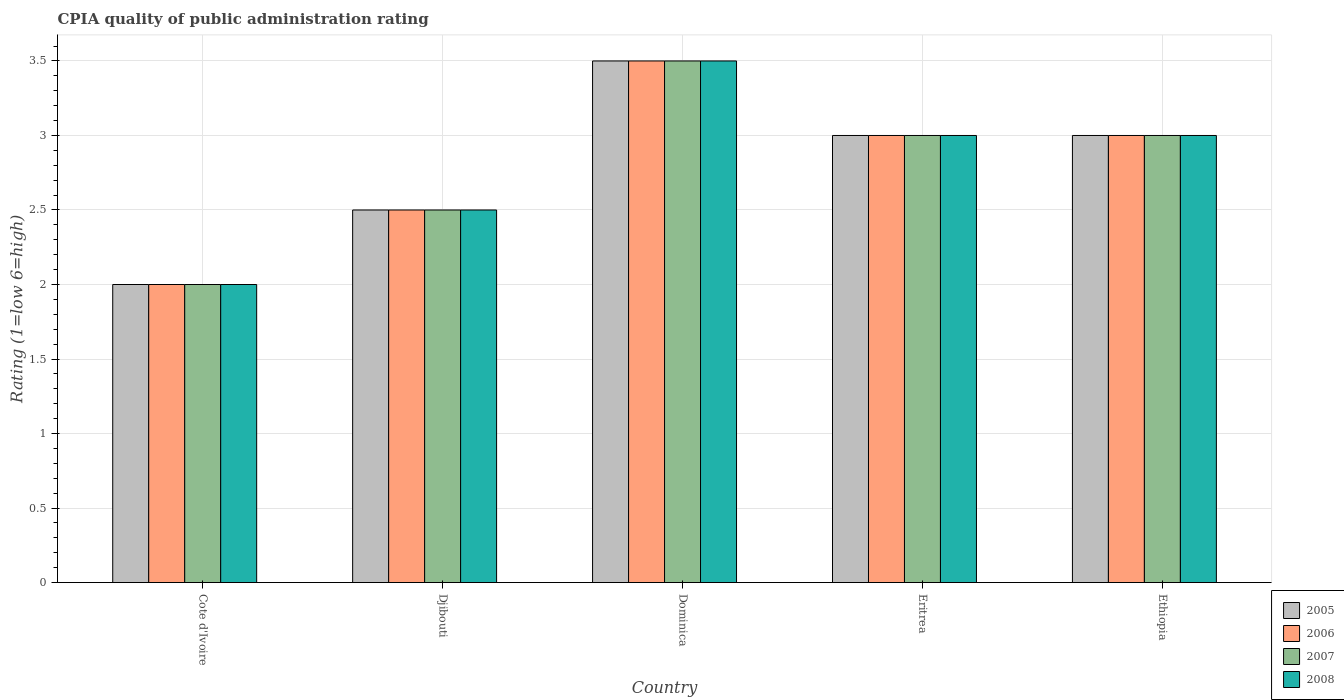How many bars are there on the 5th tick from the left?
Provide a short and direct response. 4. How many bars are there on the 5th tick from the right?
Offer a terse response. 4. What is the label of the 1st group of bars from the left?
Provide a succinct answer. Cote d'Ivoire. Across all countries, what is the maximum CPIA rating in 2005?
Your answer should be compact. 3.5. Across all countries, what is the minimum CPIA rating in 2005?
Provide a short and direct response. 2. In which country was the CPIA rating in 2008 maximum?
Make the answer very short. Dominica. In which country was the CPIA rating in 2008 minimum?
Ensure brevity in your answer.  Cote d'Ivoire. What is the total CPIA rating in 2008 in the graph?
Your answer should be very brief. 14. What is the difference between the CPIA rating in 2005 in Eritrea and the CPIA rating in 2006 in Cote d'Ivoire?
Ensure brevity in your answer.  1. Is the CPIA rating in 2007 in Dominica less than that in Eritrea?
Provide a short and direct response. No. Is the difference between the CPIA rating in 2007 in Djibouti and Dominica greater than the difference between the CPIA rating in 2008 in Djibouti and Dominica?
Offer a terse response. No. What is the difference between the highest and the second highest CPIA rating in 2005?
Make the answer very short. -0.5. In how many countries, is the CPIA rating in 2007 greater than the average CPIA rating in 2007 taken over all countries?
Offer a terse response. 3. Is the sum of the CPIA rating in 2005 in Djibouti and Eritrea greater than the maximum CPIA rating in 2007 across all countries?
Your answer should be compact. Yes. What does the 2nd bar from the left in Ethiopia represents?
Give a very brief answer. 2006. What does the 4th bar from the right in Ethiopia represents?
Keep it short and to the point. 2005. Is it the case that in every country, the sum of the CPIA rating in 2006 and CPIA rating in 2005 is greater than the CPIA rating in 2007?
Ensure brevity in your answer.  Yes. How many bars are there?
Your answer should be very brief. 20. How many countries are there in the graph?
Make the answer very short. 5. What is the difference between two consecutive major ticks on the Y-axis?
Make the answer very short. 0.5. Does the graph contain any zero values?
Your response must be concise. No. Does the graph contain grids?
Provide a succinct answer. Yes. What is the title of the graph?
Ensure brevity in your answer.  CPIA quality of public administration rating. Does "1990" appear as one of the legend labels in the graph?
Offer a very short reply. No. What is the Rating (1=low 6=high) in 2006 in Cote d'Ivoire?
Offer a very short reply. 2. What is the Rating (1=low 6=high) in 2006 in Djibouti?
Offer a very short reply. 2.5. What is the Rating (1=low 6=high) of 2007 in Djibouti?
Ensure brevity in your answer.  2.5. What is the Rating (1=low 6=high) of 2008 in Djibouti?
Your answer should be compact. 2.5. What is the Rating (1=low 6=high) of 2007 in Dominica?
Offer a very short reply. 3.5. What is the Rating (1=low 6=high) in 2005 in Eritrea?
Your answer should be very brief. 3. What is the Rating (1=low 6=high) of 2006 in Eritrea?
Your answer should be compact. 3. What is the Rating (1=low 6=high) in 2007 in Eritrea?
Offer a terse response. 3. What is the Rating (1=low 6=high) of 2008 in Eritrea?
Provide a succinct answer. 3. What is the Rating (1=low 6=high) of 2006 in Ethiopia?
Your response must be concise. 3. What is the Rating (1=low 6=high) in 2008 in Ethiopia?
Keep it short and to the point. 3. Across all countries, what is the maximum Rating (1=low 6=high) of 2005?
Provide a short and direct response. 3.5. Across all countries, what is the maximum Rating (1=low 6=high) in 2007?
Your response must be concise. 3.5. What is the total Rating (1=low 6=high) in 2006 in the graph?
Provide a short and direct response. 14. What is the difference between the Rating (1=low 6=high) in 2005 in Cote d'Ivoire and that in Djibouti?
Provide a short and direct response. -0.5. What is the difference between the Rating (1=low 6=high) in 2006 in Cote d'Ivoire and that in Djibouti?
Provide a short and direct response. -0.5. What is the difference between the Rating (1=low 6=high) in 2008 in Cote d'Ivoire and that in Djibouti?
Offer a terse response. -0.5. What is the difference between the Rating (1=low 6=high) of 2007 in Cote d'Ivoire and that in Dominica?
Keep it short and to the point. -1.5. What is the difference between the Rating (1=low 6=high) in 2006 in Cote d'Ivoire and that in Eritrea?
Give a very brief answer. -1. What is the difference between the Rating (1=low 6=high) of 2005 in Cote d'Ivoire and that in Ethiopia?
Make the answer very short. -1. What is the difference between the Rating (1=low 6=high) of 2008 in Cote d'Ivoire and that in Ethiopia?
Offer a terse response. -1. What is the difference between the Rating (1=low 6=high) in 2007 in Djibouti and that in Dominica?
Offer a terse response. -1. What is the difference between the Rating (1=low 6=high) in 2005 in Djibouti and that in Eritrea?
Your answer should be very brief. -0.5. What is the difference between the Rating (1=low 6=high) of 2008 in Djibouti and that in Eritrea?
Offer a terse response. -0.5. What is the difference between the Rating (1=low 6=high) in 2007 in Djibouti and that in Ethiopia?
Your response must be concise. -0.5. What is the difference between the Rating (1=low 6=high) in 2008 in Djibouti and that in Ethiopia?
Give a very brief answer. -0.5. What is the difference between the Rating (1=low 6=high) of 2005 in Dominica and that in Eritrea?
Your answer should be very brief. 0.5. What is the difference between the Rating (1=low 6=high) in 2007 in Dominica and that in Eritrea?
Your answer should be very brief. 0.5. What is the difference between the Rating (1=low 6=high) of 2005 in Dominica and that in Ethiopia?
Offer a terse response. 0.5. What is the difference between the Rating (1=low 6=high) in 2007 in Dominica and that in Ethiopia?
Provide a short and direct response. 0.5. What is the difference between the Rating (1=low 6=high) in 2005 in Eritrea and that in Ethiopia?
Your response must be concise. 0. What is the difference between the Rating (1=low 6=high) of 2005 in Cote d'Ivoire and the Rating (1=low 6=high) of 2006 in Djibouti?
Offer a very short reply. -0.5. What is the difference between the Rating (1=low 6=high) in 2005 in Cote d'Ivoire and the Rating (1=low 6=high) in 2007 in Djibouti?
Ensure brevity in your answer.  -0.5. What is the difference between the Rating (1=low 6=high) of 2006 in Cote d'Ivoire and the Rating (1=low 6=high) of 2007 in Djibouti?
Offer a terse response. -0.5. What is the difference between the Rating (1=low 6=high) of 2007 in Cote d'Ivoire and the Rating (1=low 6=high) of 2008 in Djibouti?
Ensure brevity in your answer.  -0.5. What is the difference between the Rating (1=low 6=high) in 2005 in Cote d'Ivoire and the Rating (1=low 6=high) in 2006 in Dominica?
Your answer should be very brief. -1.5. What is the difference between the Rating (1=low 6=high) in 2006 in Cote d'Ivoire and the Rating (1=low 6=high) in 2008 in Dominica?
Keep it short and to the point. -1.5. What is the difference between the Rating (1=low 6=high) of 2005 in Cote d'Ivoire and the Rating (1=low 6=high) of 2006 in Eritrea?
Offer a terse response. -1. What is the difference between the Rating (1=low 6=high) in 2006 in Cote d'Ivoire and the Rating (1=low 6=high) in 2008 in Eritrea?
Your answer should be very brief. -1. What is the difference between the Rating (1=low 6=high) of 2007 in Cote d'Ivoire and the Rating (1=low 6=high) of 2008 in Eritrea?
Your answer should be very brief. -1. What is the difference between the Rating (1=low 6=high) of 2005 in Cote d'Ivoire and the Rating (1=low 6=high) of 2006 in Ethiopia?
Offer a very short reply. -1. What is the difference between the Rating (1=low 6=high) in 2006 in Cote d'Ivoire and the Rating (1=low 6=high) in 2007 in Ethiopia?
Your answer should be compact. -1. What is the difference between the Rating (1=low 6=high) in 2006 in Cote d'Ivoire and the Rating (1=low 6=high) in 2008 in Ethiopia?
Your answer should be very brief. -1. What is the difference between the Rating (1=low 6=high) of 2007 in Cote d'Ivoire and the Rating (1=low 6=high) of 2008 in Ethiopia?
Offer a terse response. -1. What is the difference between the Rating (1=low 6=high) of 2005 in Djibouti and the Rating (1=low 6=high) of 2007 in Dominica?
Give a very brief answer. -1. What is the difference between the Rating (1=low 6=high) of 2005 in Djibouti and the Rating (1=low 6=high) of 2008 in Dominica?
Your answer should be very brief. -1. What is the difference between the Rating (1=low 6=high) of 2007 in Djibouti and the Rating (1=low 6=high) of 2008 in Eritrea?
Your response must be concise. -0.5. What is the difference between the Rating (1=low 6=high) in 2005 in Djibouti and the Rating (1=low 6=high) in 2006 in Ethiopia?
Provide a succinct answer. -0.5. What is the difference between the Rating (1=low 6=high) of 2005 in Djibouti and the Rating (1=low 6=high) of 2007 in Ethiopia?
Provide a short and direct response. -0.5. What is the difference between the Rating (1=low 6=high) of 2005 in Djibouti and the Rating (1=low 6=high) of 2008 in Ethiopia?
Keep it short and to the point. -0.5. What is the difference between the Rating (1=low 6=high) in 2007 in Djibouti and the Rating (1=low 6=high) in 2008 in Ethiopia?
Keep it short and to the point. -0.5. What is the difference between the Rating (1=low 6=high) of 2005 in Dominica and the Rating (1=low 6=high) of 2006 in Eritrea?
Offer a terse response. 0.5. What is the difference between the Rating (1=low 6=high) in 2005 in Dominica and the Rating (1=low 6=high) in 2007 in Eritrea?
Provide a short and direct response. 0.5. What is the difference between the Rating (1=low 6=high) of 2005 in Dominica and the Rating (1=low 6=high) of 2008 in Eritrea?
Make the answer very short. 0.5. What is the difference between the Rating (1=low 6=high) of 2006 in Dominica and the Rating (1=low 6=high) of 2007 in Eritrea?
Offer a terse response. 0.5. What is the difference between the Rating (1=low 6=high) of 2006 in Dominica and the Rating (1=low 6=high) of 2008 in Eritrea?
Your answer should be compact. 0.5. What is the difference between the Rating (1=low 6=high) in 2007 in Dominica and the Rating (1=low 6=high) in 2008 in Eritrea?
Your response must be concise. 0.5. What is the difference between the Rating (1=low 6=high) of 2005 in Dominica and the Rating (1=low 6=high) of 2008 in Ethiopia?
Provide a short and direct response. 0.5. What is the difference between the Rating (1=low 6=high) of 2005 in Eritrea and the Rating (1=low 6=high) of 2006 in Ethiopia?
Provide a short and direct response. 0. What is the difference between the Rating (1=low 6=high) of 2007 in Eritrea and the Rating (1=low 6=high) of 2008 in Ethiopia?
Make the answer very short. 0. What is the average Rating (1=low 6=high) of 2007 per country?
Keep it short and to the point. 2.8. What is the difference between the Rating (1=low 6=high) of 2005 and Rating (1=low 6=high) of 2007 in Cote d'Ivoire?
Make the answer very short. 0. What is the difference between the Rating (1=low 6=high) of 2005 and Rating (1=low 6=high) of 2008 in Cote d'Ivoire?
Your response must be concise. 0. What is the difference between the Rating (1=low 6=high) of 2006 and Rating (1=low 6=high) of 2008 in Cote d'Ivoire?
Offer a very short reply. 0. What is the difference between the Rating (1=low 6=high) in 2005 and Rating (1=low 6=high) in 2007 in Djibouti?
Provide a succinct answer. 0. What is the difference between the Rating (1=low 6=high) of 2005 and Rating (1=low 6=high) of 2008 in Djibouti?
Give a very brief answer. 0. What is the difference between the Rating (1=low 6=high) in 2006 and Rating (1=low 6=high) in 2007 in Djibouti?
Make the answer very short. 0. What is the difference between the Rating (1=low 6=high) of 2007 and Rating (1=low 6=high) of 2008 in Djibouti?
Your answer should be very brief. 0. What is the difference between the Rating (1=low 6=high) in 2005 and Rating (1=low 6=high) in 2008 in Dominica?
Your answer should be compact. 0. What is the difference between the Rating (1=low 6=high) in 2006 and Rating (1=low 6=high) in 2007 in Dominica?
Give a very brief answer. 0. What is the difference between the Rating (1=low 6=high) of 2007 and Rating (1=low 6=high) of 2008 in Dominica?
Your answer should be very brief. 0. What is the difference between the Rating (1=low 6=high) in 2006 and Rating (1=low 6=high) in 2007 in Eritrea?
Offer a terse response. 0. What is the difference between the Rating (1=low 6=high) of 2006 and Rating (1=low 6=high) of 2007 in Ethiopia?
Ensure brevity in your answer.  0. What is the difference between the Rating (1=low 6=high) in 2007 and Rating (1=low 6=high) in 2008 in Ethiopia?
Provide a short and direct response. 0. What is the ratio of the Rating (1=low 6=high) in 2005 in Cote d'Ivoire to that in Djibouti?
Offer a terse response. 0.8. What is the ratio of the Rating (1=low 6=high) of 2006 in Cote d'Ivoire to that in Djibouti?
Your answer should be compact. 0.8. What is the ratio of the Rating (1=low 6=high) of 2006 in Cote d'Ivoire to that in Dominica?
Your answer should be very brief. 0.57. What is the ratio of the Rating (1=low 6=high) of 2005 in Cote d'Ivoire to that in Eritrea?
Provide a short and direct response. 0.67. What is the ratio of the Rating (1=low 6=high) in 2006 in Cote d'Ivoire to that in Eritrea?
Make the answer very short. 0.67. What is the ratio of the Rating (1=low 6=high) of 2007 in Cote d'Ivoire to that in Eritrea?
Keep it short and to the point. 0.67. What is the ratio of the Rating (1=low 6=high) in 2005 in Cote d'Ivoire to that in Ethiopia?
Ensure brevity in your answer.  0.67. What is the ratio of the Rating (1=low 6=high) in 2007 in Cote d'Ivoire to that in Ethiopia?
Offer a very short reply. 0.67. What is the ratio of the Rating (1=low 6=high) in 2008 in Djibouti to that in Dominica?
Your response must be concise. 0.71. What is the ratio of the Rating (1=low 6=high) in 2006 in Djibouti to that in Eritrea?
Your answer should be very brief. 0.83. What is the ratio of the Rating (1=low 6=high) of 2007 in Djibouti to that in Eritrea?
Keep it short and to the point. 0.83. What is the ratio of the Rating (1=low 6=high) of 2007 in Djibouti to that in Ethiopia?
Your response must be concise. 0.83. What is the ratio of the Rating (1=low 6=high) of 2008 in Djibouti to that in Ethiopia?
Provide a succinct answer. 0.83. What is the ratio of the Rating (1=low 6=high) of 2005 in Dominica to that in Eritrea?
Your response must be concise. 1.17. What is the ratio of the Rating (1=low 6=high) of 2007 in Dominica to that in Eritrea?
Provide a short and direct response. 1.17. What is the ratio of the Rating (1=low 6=high) of 2008 in Dominica to that in Eritrea?
Provide a short and direct response. 1.17. What is the ratio of the Rating (1=low 6=high) in 2005 in Dominica to that in Ethiopia?
Ensure brevity in your answer.  1.17. What is the ratio of the Rating (1=low 6=high) of 2006 in Dominica to that in Ethiopia?
Provide a succinct answer. 1.17. What is the ratio of the Rating (1=low 6=high) of 2006 in Eritrea to that in Ethiopia?
Provide a short and direct response. 1. What is the difference between the highest and the second highest Rating (1=low 6=high) of 2006?
Offer a terse response. 0.5. What is the difference between the highest and the second highest Rating (1=low 6=high) of 2007?
Provide a succinct answer. 0.5. What is the difference between the highest and the lowest Rating (1=low 6=high) in 2006?
Your answer should be very brief. 1.5. 